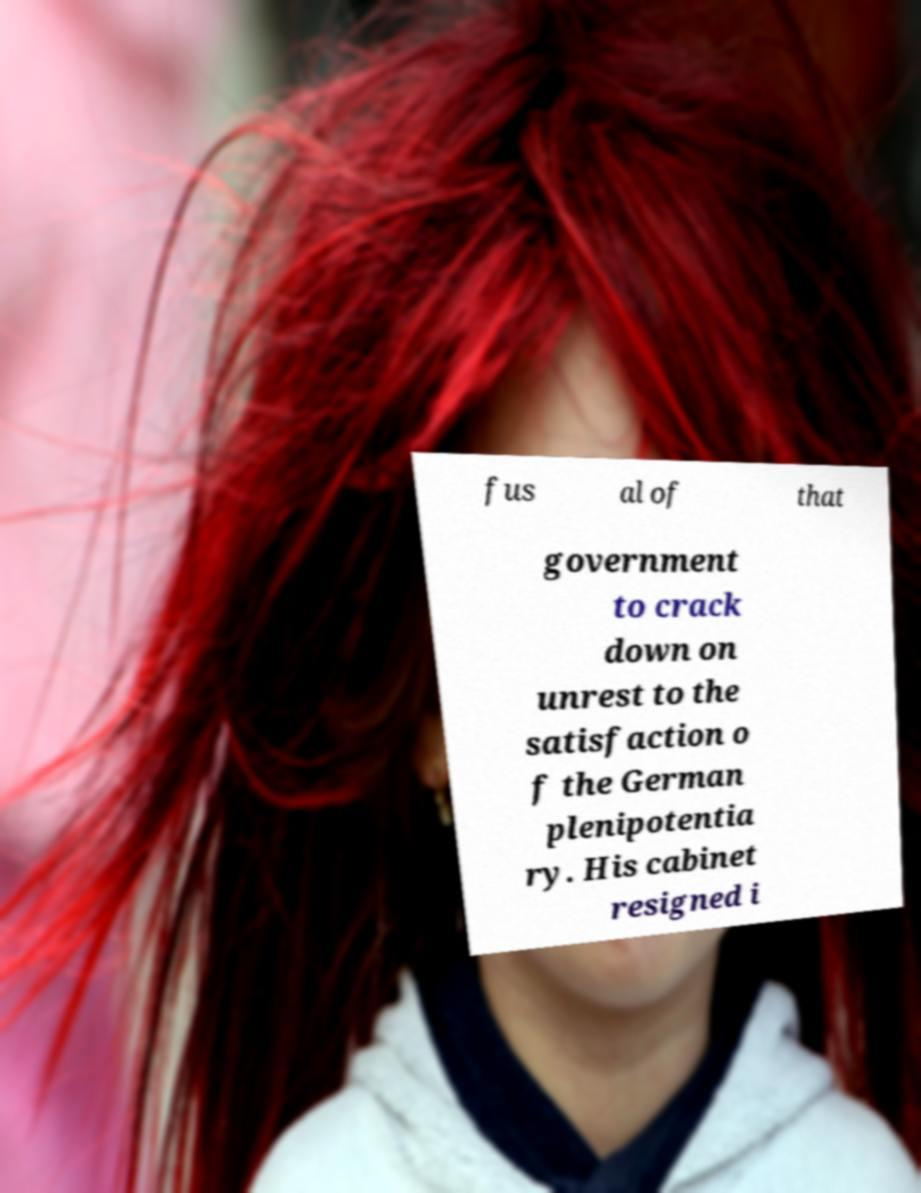Please read and relay the text visible in this image. What does it say? fus al of that government to crack down on unrest to the satisfaction o f the German plenipotentia ry. His cabinet resigned i 